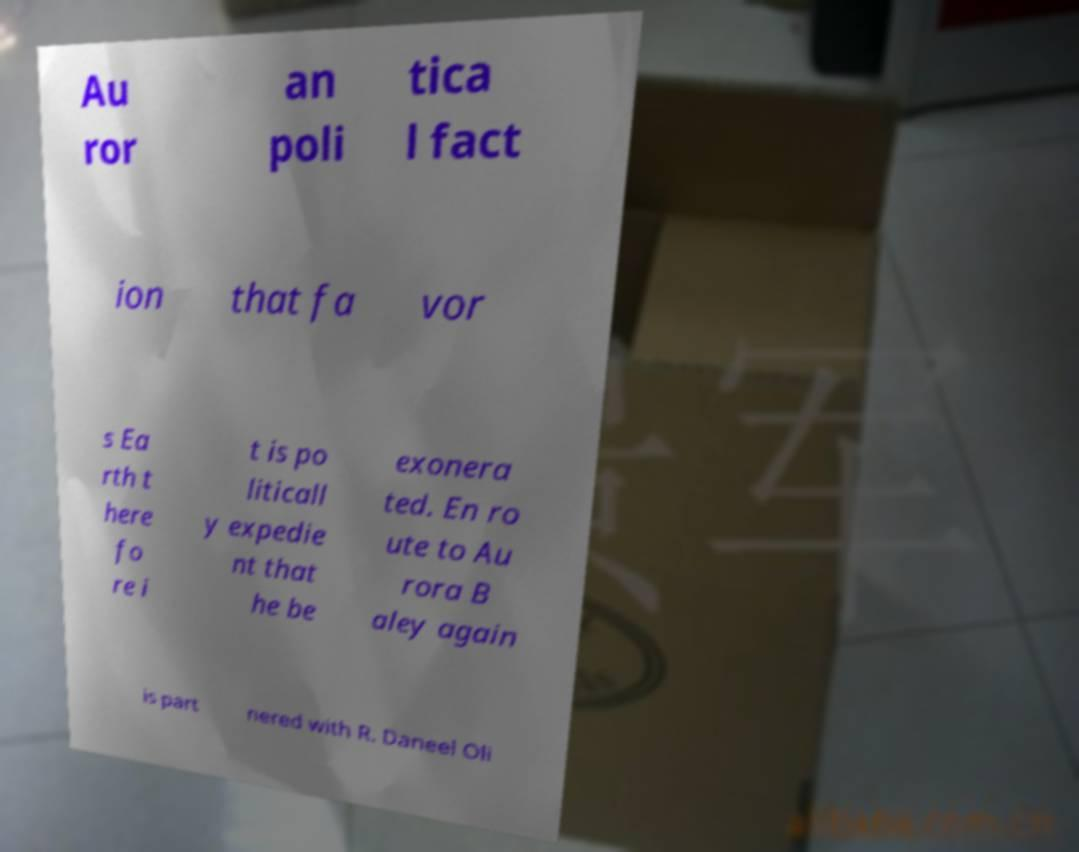What messages or text are displayed in this image? I need them in a readable, typed format. Au ror an poli tica l fact ion that fa vor s Ea rth t here fo re i t is po liticall y expedie nt that he be exonera ted. En ro ute to Au rora B aley again is part nered with R. Daneel Oli 